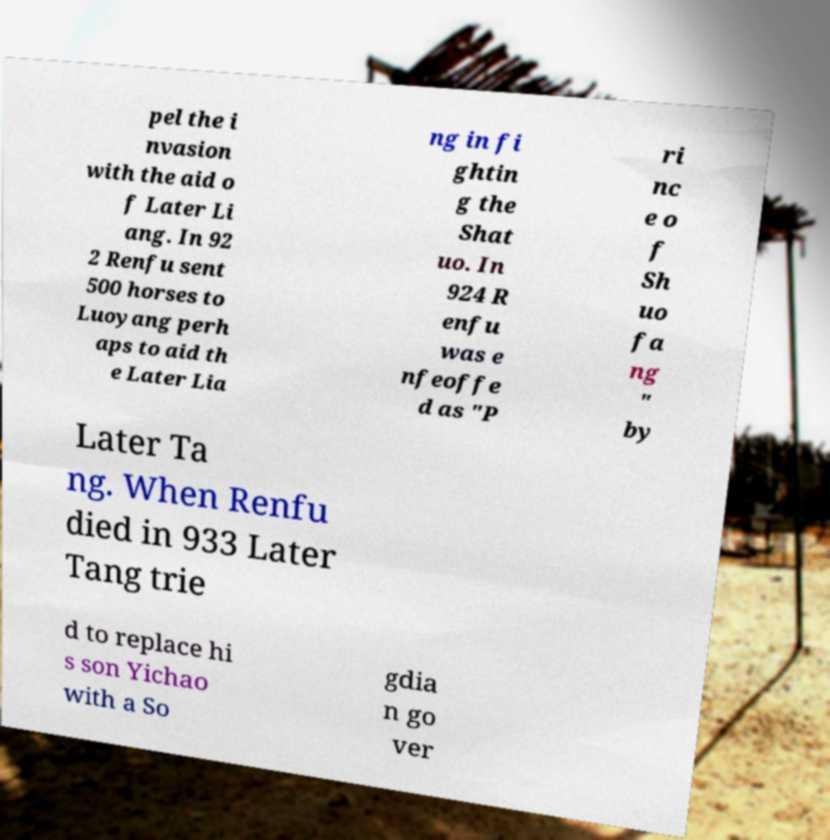For documentation purposes, I need the text within this image transcribed. Could you provide that? pel the i nvasion with the aid o f Later Li ang. In 92 2 Renfu sent 500 horses to Luoyang perh aps to aid th e Later Lia ng in fi ghtin g the Shat uo. In 924 R enfu was e nfeoffe d as "P ri nc e o f Sh uo fa ng " by Later Ta ng. When Renfu died in 933 Later Tang trie d to replace hi s son Yichao with a So gdia n go ver 